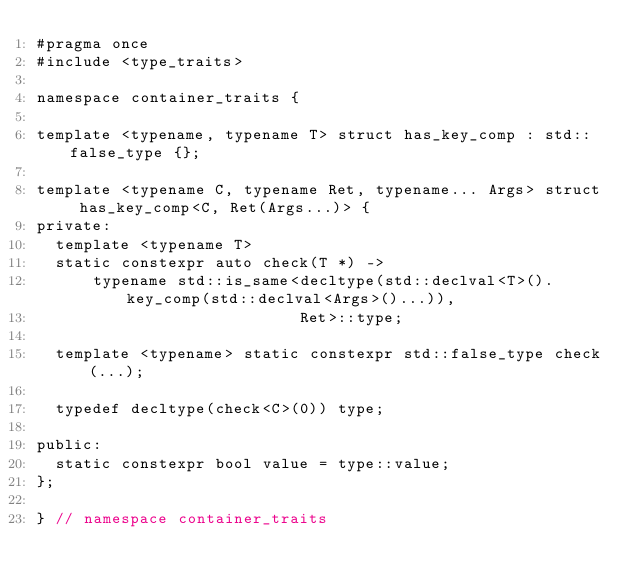Convert code to text. <code><loc_0><loc_0><loc_500><loc_500><_C_>#pragma once
#include <type_traits>

namespace container_traits {

template <typename, typename T> struct has_key_comp : std::false_type {};

template <typename C, typename Ret, typename... Args> struct has_key_comp<C, Ret(Args...)> {
private:
  template <typename T>
  static constexpr auto check(T *) ->
      typename std::is_same<decltype(std::declval<T>().key_comp(std::declval<Args>()...)),
                            Ret>::type;

  template <typename> static constexpr std::false_type check(...);

  typedef decltype(check<C>(0)) type;

public:
  static constexpr bool value = type::value;
};

} // namespace container_traits</code> 